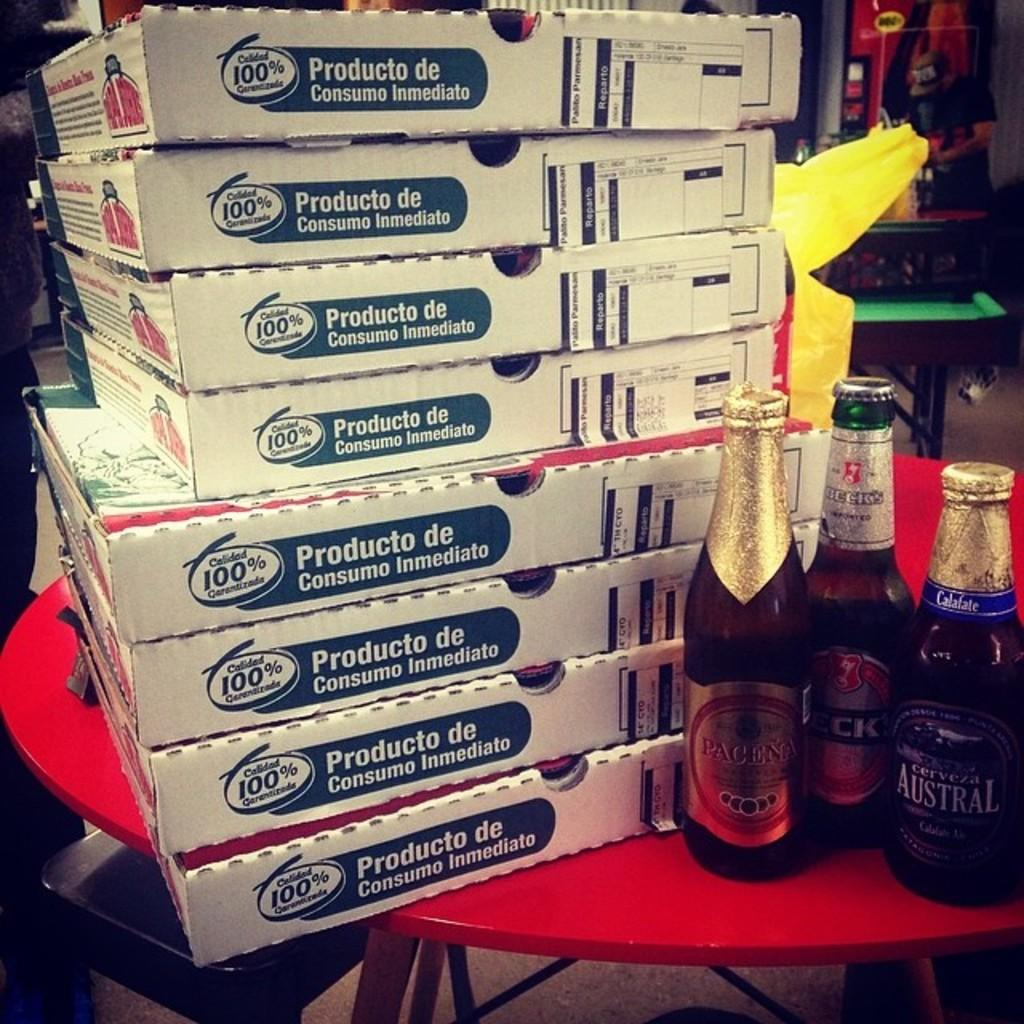<image>
Write a terse but informative summary of the picture. Several boxes sit on a table besdie beer bottles Pacena, Becks and Austral 